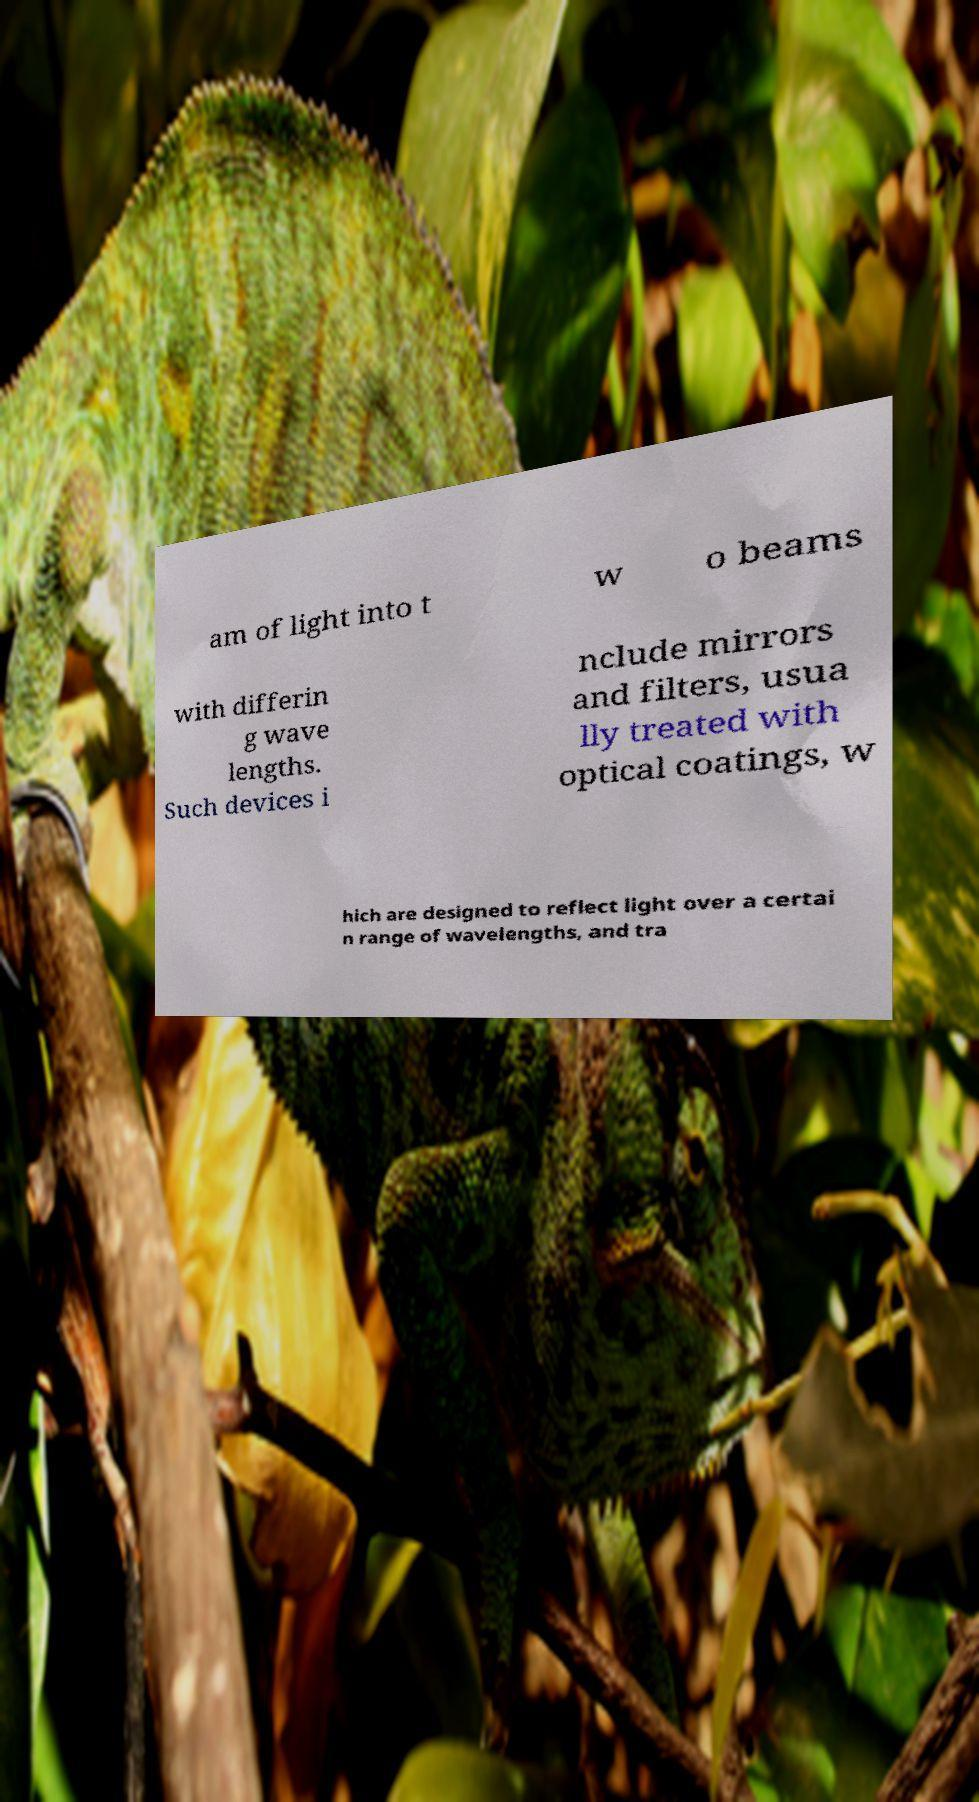What messages or text are displayed in this image? I need them in a readable, typed format. am of light into t w o beams with differin g wave lengths. Such devices i nclude mirrors and filters, usua lly treated with optical coatings, w hich are designed to reflect light over a certai n range of wavelengths, and tra 